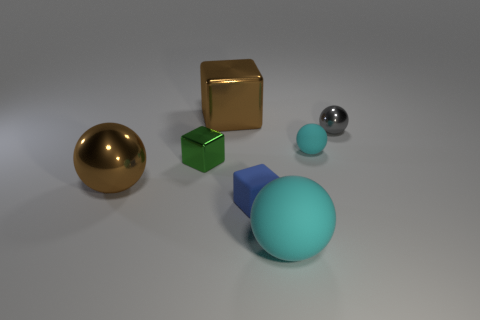Subtract all brown spheres. How many spheres are left? 3 Subtract all brown balls. How many balls are left? 3 Subtract 1 balls. How many balls are left? 3 Add 2 large brown metallic blocks. How many objects exist? 9 Subtract all cubes. How many objects are left? 4 Add 6 big metal objects. How many big metal objects are left? 8 Add 3 big cyan matte balls. How many big cyan matte balls exist? 4 Subtract 0 brown cylinders. How many objects are left? 7 Subtract all cyan cubes. Subtract all gray balls. How many cubes are left? 3 Subtract all red cubes. How many yellow spheres are left? 0 